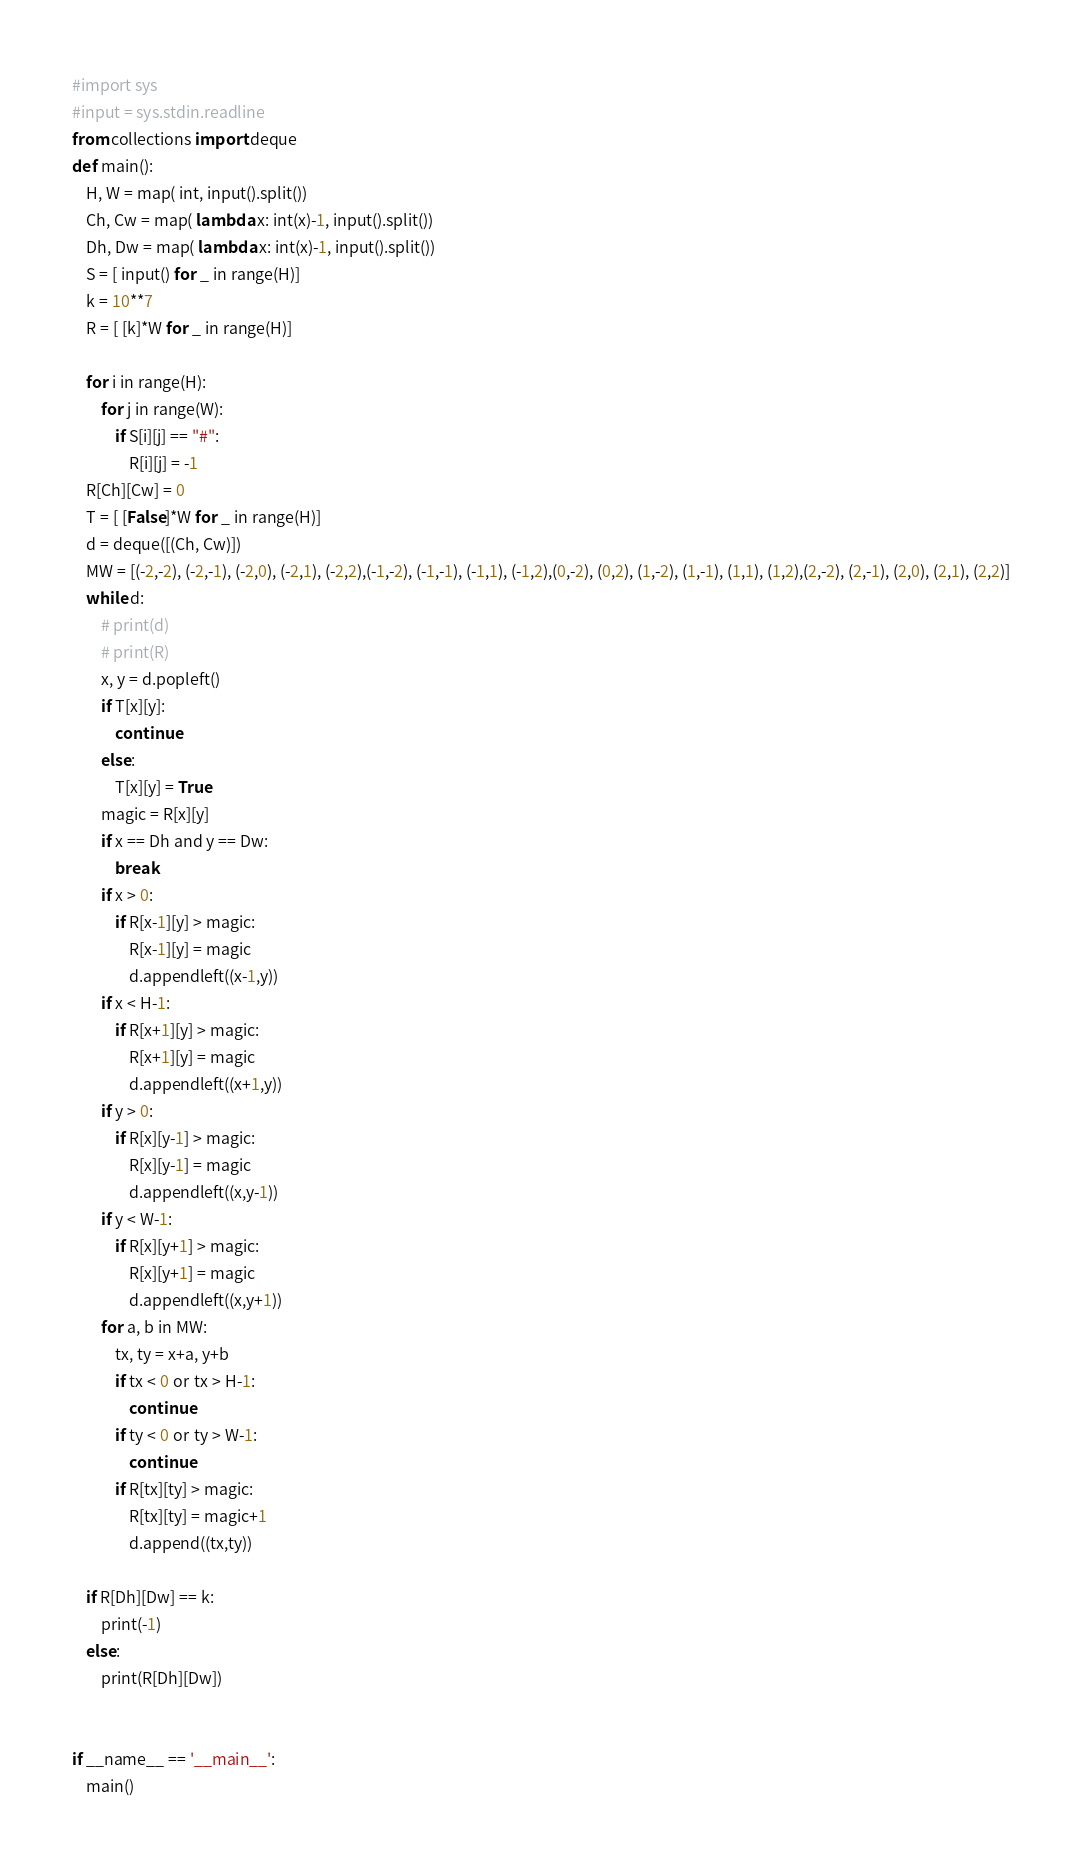Convert code to text. <code><loc_0><loc_0><loc_500><loc_500><_Python_>#import sys
#input = sys.stdin.readline
from collections import deque
def main():
    H, W = map( int, input().split())
    Ch, Cw = map( lambda x: int(x)-1, input().split())
    Dh, Dw = map( lambda x: int(x)-1, input().split())
    S = [ input() for _ in range(H)]
    k = 10**7
    R = [ [k]*W for _ in range(H)]

    for i in range(H):
        for j in range(W):
            if S[i][j] == "#":
                R[i][j] = -1
    R[Ch][Cw] = 0
    T = [ [False]*W for _ in range(H)]
    d = deque([(Ch, Cw)])
    MW = [(-2,-2), (-2,-1), (-2,0), (-2,1), (-2,2),(-1,-2), (-1,-1), (-1,1), (-1,2),(0,-2), (0,2), (1,-2), (1,-1), (1,1), (1,2),(2,-2), (2,-1), (2,0), (2,1), (2,2)]
    while d:
        # print(d)
        # print(R)
        x, y = d.popleft()
        if T[x][y]:
            continue
        else:
            T[x][y] = True
        magic = R[x][y]
        if x == Dh and y == Dw:
            break
        if x > 0:
            if R[x-1][y] > magic:
                R[x-1][y] = magic
                d.appendleft((x-1,y))
        if x < H-1:
            if R[x+1][y] > magic:
                R[x+1][y] = magic
                d.appendleft((x+1,y))
        if y > 0:
            if R[x][y-1] > magic:
                R[x][y-1] = magic
                d.appendleft((x,y-1))
        if y < W-1:
            if R[x][y+1] > magic:
                R[x][y+1] = magic
                d.appendleft((x,y+1))
        for a, b in MW:
            tx, ty = x+a, y+b
            if tx < 0 or tx > H-1:
                continue
            if ty < 0 or ty > W-1:
                continue
            if R[tx][ty] > magic:
                R[tx][ty] = magic+1
                d.append((tx,ty))

    if R[Dh][Dw] == k:
        print(-1)
    else:
        print(R[Dh][Dw])
        
    
if __name__ == '__main__':
    main()
</code> 